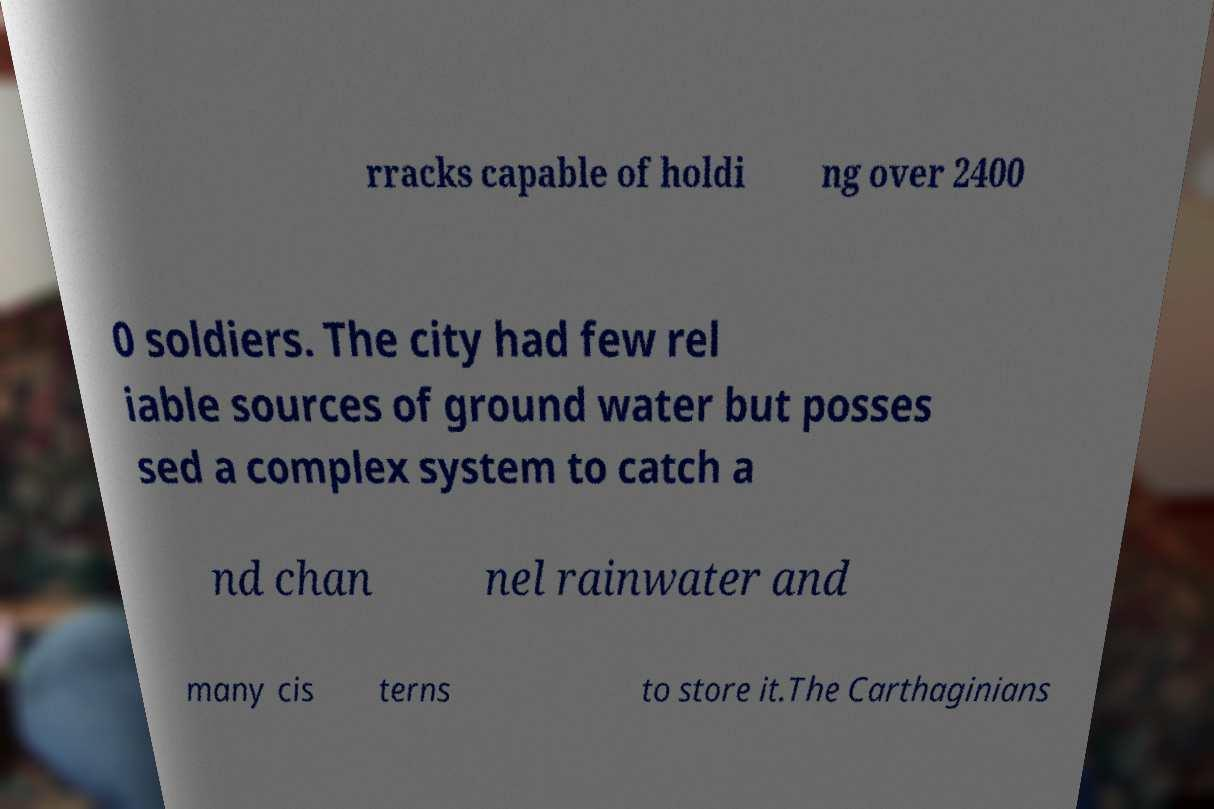Please read and relay the text visible in this image. What does it say? rracks capable of holdi ng over 2400 0 soldiers. The city had few rel iable sources of ground water but posses sed a complex system to catch a nd chan nel rainwater and many cis terns to store it.The Carthaginians 